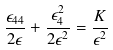<formula> <loc_0><loc_0><loc_500><loc_500>\frac { \epsilon _ { 4 4 } } { 2 \epsilon } + \frac { \epsilon ^ { 2 } _ { 4 } } { 2 \epsilon ^ { 2 } } = \frac { K } { \epsilon ^ { 2 } }</formula> 